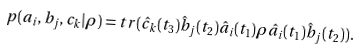<formula> <loc_0><loc_0><loc_500><loc_500>p ( a _ { i } , b _ { j } , c _ { k } | \rho ) = t r ( \hat { c } _ { k } ( t _ { 3 } ) \hat { b } _ { j } ( t _ { 2 } ) \hat { a } _ { i } ( t _ { 1 } ) \rho \hat { a } _ { i } ( t _ { 1 } ) \hat { b } _ { j } ( t _ { 2 } ) ) .</formula> 